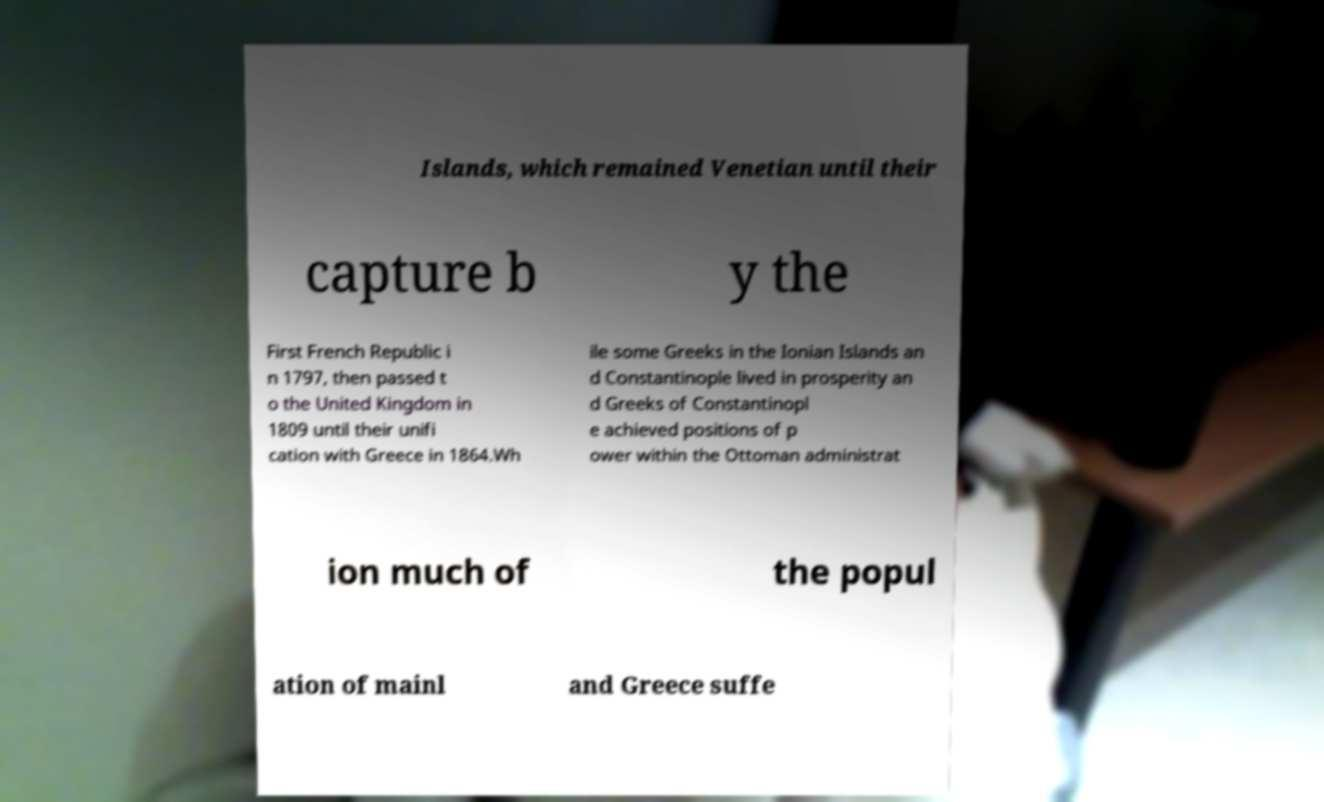Could you extract and type out the text from this image? Islands, which remained Venetian until their capture b y the First French Republic i n 1797, then passed t o the United Kingdom in 1809 until their unifi cation with Greece in 1864.Wh ile some Greeks in the Ionian Islands an d Constantinople lived in prosperity an d Greeks of Constantinopl e achieved positions of p ower within the Ottoman administrat ion much of the popul ation of mainl and Greece suffe 